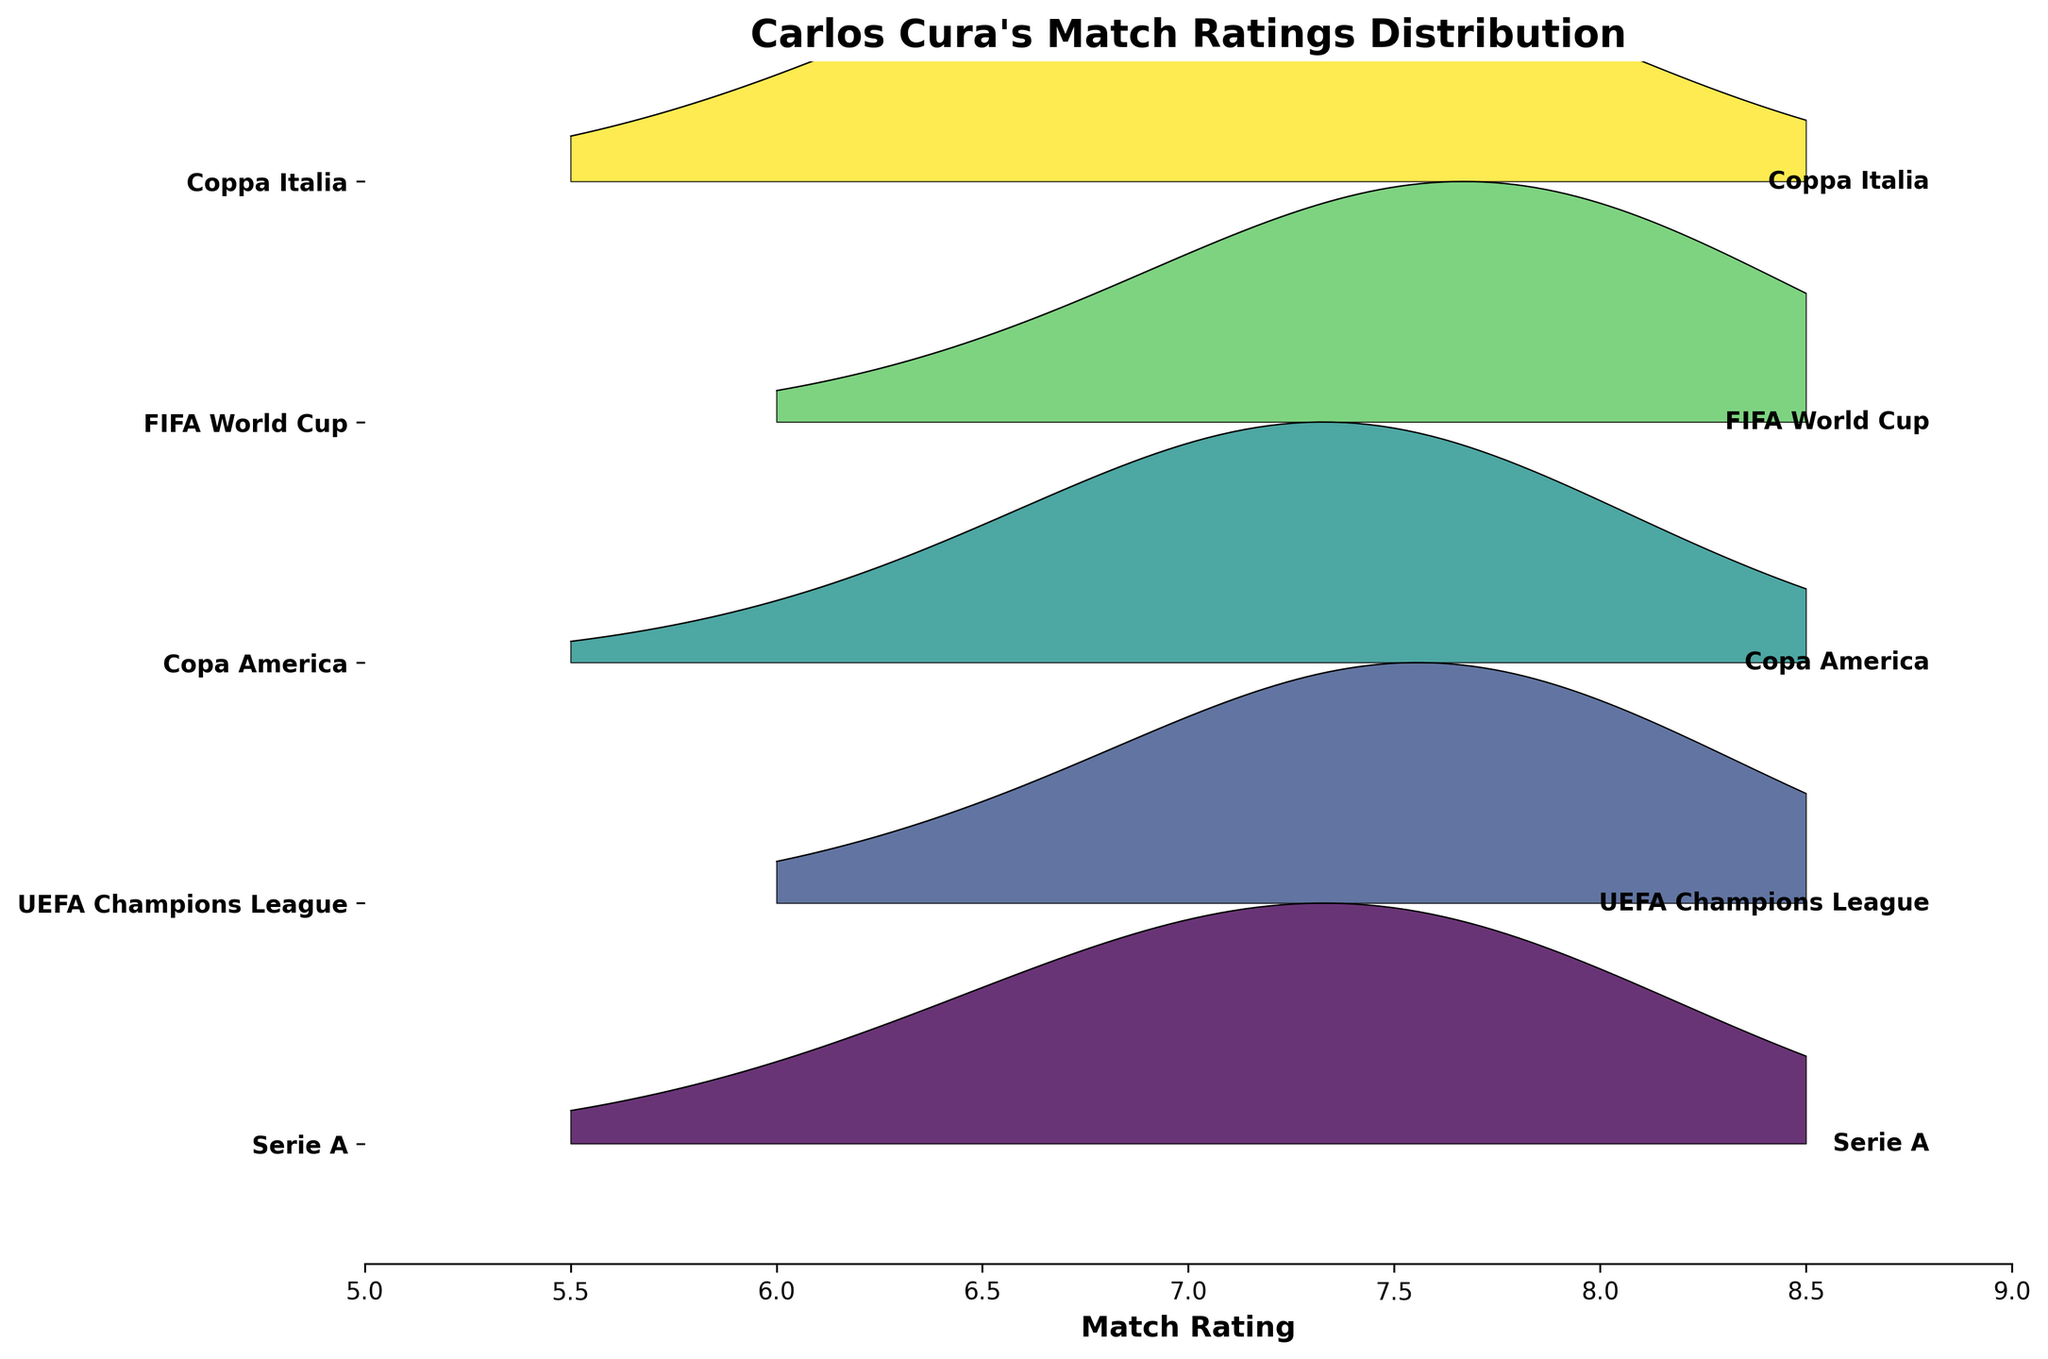What is the title of the figure? The title is typically displayed at the top center of the figure. From the code provided, the title is defined as "Carlos Cura's Match Ratings Distribution".
Answer: Carlos Cura's Match Ratings Distribution What are the labels on the y-axis? The y-axis labels are the names of the tournaments. They are extracted from the `tournament` column in the data. They include Serie A, UEFA Champions League, Copa America, FIFA World Cup, and Coppa Italia.
Answer: Serie A, UEFA Champions League, Copa America, FIFA World Cup, Coppa Italia Which tournament has the highest peak density rating? To identify the tournament with the highest peak density, we look at each tournament's ridgeline and find the maximum y-value along the rating axis. The UEFA Champions League has the highest density peak at a rating of 7.5.
Answer: UEFA Champions League What is the most frequent rating in the Serie A tournament? The most frequent rating corresponds to the highest peak in the density curve for Serie A. In the plot, the peak for Serie A is at a rating of 7.5.
Answer: 7.5 Which tournaments have a peak density at a rating of 7.0? By examining the peaks in the ridgeline plots, both the FIFA World Cup and Coppa Italia have significant peaks at a rating of 7.0.
Answer: FIFA World Cup, Coppa Italia What's the difference in density between the highest peak in Copa America and the highest peak in Serie A? The highest peak density in Copa America is at 7.5 with a density of 0.35. In Serie A, the highest peak density is also at 7.5 with a density of 0.30. The difference is 0.35 - 0.30 = 0.05.
Answer: 0.05 Which tournament has a more widespread match rating, Serie A or UEFA Champions League? To determine which tournament has a more widespread rating distribution, check the range and dispersion of the ratings. Serie A's ratings spread from 5.5 to 8.5, similar to UEFA Champions League, but UEFA Champions League has higher peaks suggesting it is more skewed. This implies UEFA Champions League ratings are less widespread than Serie A.
Answer: Serie A What's the combined density at a rating of 7.5 for all tournaments? Add up the densities at rating 7.5 for all tournaments: Serie A = 0.30, UEFA Champions League = 0.35, Copa America = 0.35, FIFA World Cup = 0.32, Coppa Italia = 0.25. Total = 0.30 + 0.35 + 0.35 + 0.32 + 0.25 = 1.57.
Answer: 1.57 At what rating does FIFA World Cup have its second highest density? The highest density for FIFA World Cup is at 7.5. The second highest peak can be observed at rating 8.0.
Answer: 8.0 